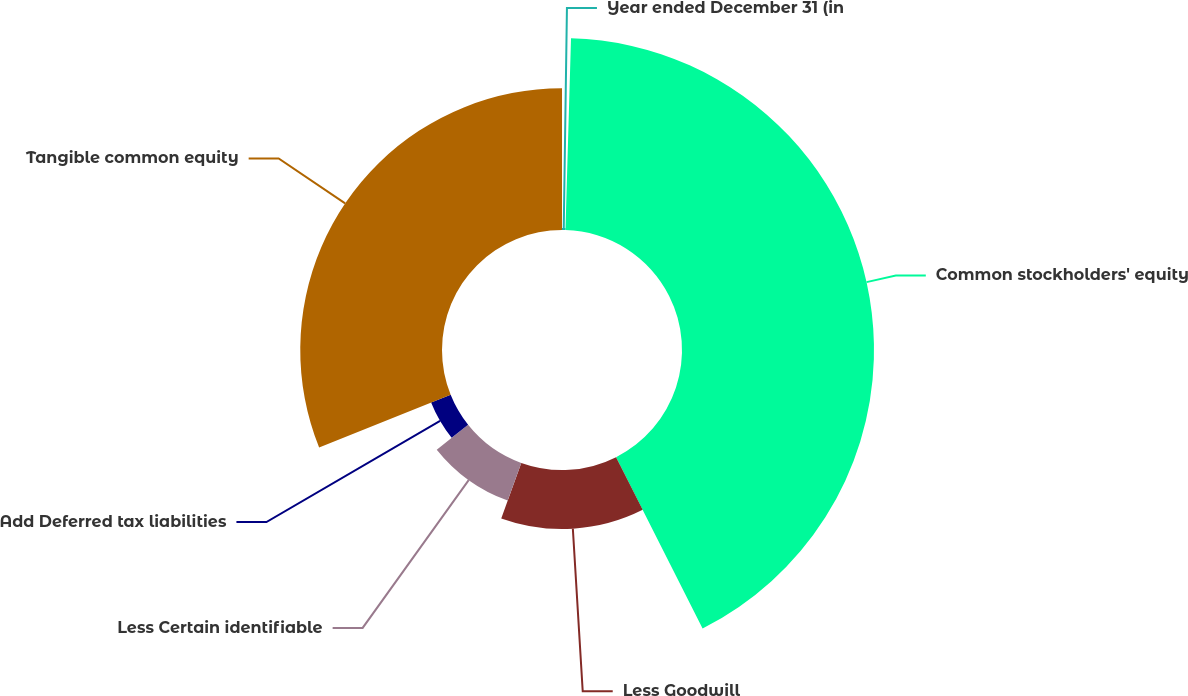Convert chart. <chart><loc_0><loc_0><loc_500><loc_500><pie_chart><fcel>Year ended December 31 (in<fcel>Common stockholders' equity<fcel>Less Goodwill<fcel>Less Certain identifiable<fcel>Add Deferred tax liabilities<fcel>Tangible common equity<nl><fcel>0.46%<fcel>42.1%<fcel>12.95%<fcel>8.79%<fcel>4.62%<fcel>31.08%<nl></chart> 